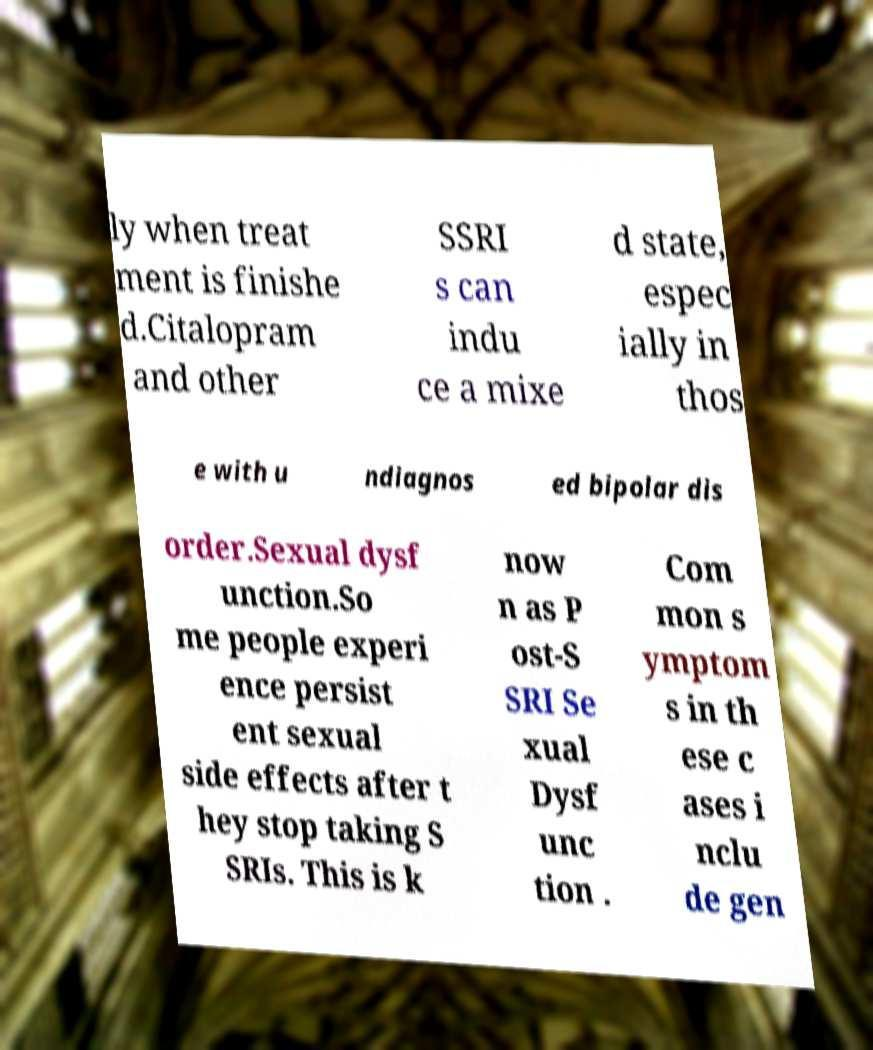Please read and relay the text visible in this image. What does it say? ly when treat ment is finishe d.Citalopram and other SSRI s can indu ce a mixe d state, espec ially in thos e with u ndiagnos ed bipolar dis order.Sexual dysf unction.So me people experi ence persist ent sexual side effects after t hey stop taking S SRIs. This is k now n as P ost-S SRI Se xual Dysf unc tion . Com mon s ymptom s in th ese c ases i nclu de gen 